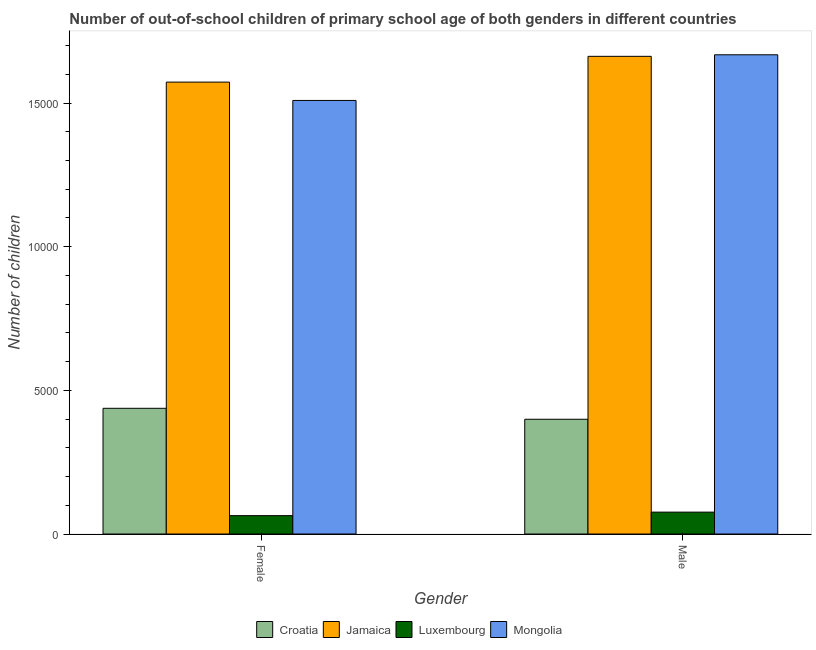How many bars are there on the 2nd tick from the left?
Your answer should be compact. 4. How many bars are there on the 1st tick from the right?
Give a very brief answer. 4. What is the label of the 1st group of bars from the left?
Give a very brief answer. Female. What is the number of female out-of-school students in Jamaica?
Your answer should be very brief. 1.57e+04. Across all countries, what is the maximum number of female out-of-school students?
Offer a very short reply. 1.57e+04. Across all countries, what is the minimum number of female out-of-school students?
Offer a terse response. 639. In which country was the number of male out-of-school students maximum?
Your answer should be compact. Mongolia. In which country was the number of female out-of-school students minimum?
Your response must be concise. Luxembourg. What is the total number of male out-of-school students in the graph?
Give a very brief answer. 3.81e+04. What is the difference between the number of female out-of-school students in Croatia and that in Jamaica?
Make the answer very short. -1.14e+04. What is the difference between the number of female out-of-school students in Croatia and the number of male out-of-school students in Jamaica?
Provide a short and direct response. -1.23e+04. What is the average number of male out-of-school students per country?
Provide a succinct answer. 9515.25. What is the difference between the number of female out-of-school students and number of male out-of-school students in Croatia?
Your answer should be very brief. 381. What is the ratio of the number of male out-of-school students in Croatia to that in Luxembourg?
Provide a succinct answer. 5.25. In how many countries, is the number of female out-of-school students greater than the average number of female out-of-school students taken over all countries?
Keep it short and to the point. 2. What does the 4th bar from the left in Female represents?
Provide a short and direct response. Mongolia. What does the 4th bar from the right in Male represents?
Your answer should be very brief. Croatia. How many bars are there?
Give a very brief answer. 8. What is the difference between two consecutive major ticks on the Y-axis?
Keep it short and to the point. 5000. Does the graph contain any zero values?
Your answer should be compact. No. Where does the legend appear in the graph?
Your response must be concise. Bottom center. How many legend labels are there?
Offer a terse response. 4. What is the title of the graph?
Offer a very short reply. Number of out-of-school children of primary school age of both genders in different countries. What is the label or title of the X-axis?
Your response must be concise. Gender. What is the label or title of the Y-axis?
Offer a very short reply. Number of children. What is the Number of children of Croatia in Female?
Your response must be concise. 4375. What is the Number of children of Jamaica in Female?
Offer a terse response. 1.57e+04. What is the Number of children in Luxembourg in Female?
Provide a short and direct response. 639. What is the Number of children of Mongolia in Female?
Your answer should be very brief. 1.51e+04. What is the Number of children of Croatia in Male?
Offer a very short reply. 3994. What is the Number of children of Jamaica in Male?
Your response must be concise. 1.66e+04. What is the Number of children of Luxembourg in Male?
Provide a succinct answer. 761. What is the Number of children in Mongolia in Male?
Ensure brevity in your answer.  1.67e+04. Across all Gender, what is the maximum Number of children in Croatia?
Offer a very short reply. 4375. Across all Gender, what is the maximum Number of children in Jamaica?
Your answer should be very brief. 1.66e+04. Across all Gender, what is the maximum Number of children in Luxembourg?
Ensure brevity in your answer.  761. Across all Gender, what is the maximum Number of children of Mongolia?
Give a very brief answer. 1.67e+04. Across all Gender, what is the minimum Number of children in Croatia?
Offer a terse response. 3994. Across all Gender, what is the minimum Number of children in Jamaica?
Keep it short and to the point. 1.57e+04. Across all Gender, what is the minimum Number of children of Luxembourg?
Keep it short and to the point. 639. Across all Gender, what is the minimum Number of children of Mongolia?
Give a very brief answer. 1.51e+04. What is the total Number of children of Croatia in the graph?
Your answer should be compact. 8369. What is the total Number of children in Jamaica in the graph?
Make the answer very short. 3.24e+04. What is the total Number of children of Luxembourg in the graph?
Provide a short and direct response. 1400. What is the total Number of children of Mongolia in the graph?
Provide a succinct answer. 3.18e+04. What is the difference between the Number of children of Croatia in Female and that in Male?
Your answer should be very brief. 381. What is the difference between the Number of children of Jamaica in Female and that in Male?
Your response must be concise. -897. What is the difference between the Number of children in Luxembourg in Female and that in Male?
Ensure brevity in your answer.  -122. What is the difference between the Number of children in Mongolia in Female and that in Male?
Make the answer very short. -1589. What is the difference between the Number of children in Croatia in Female and the Number of children in Jamaica in Male?
Make the answer very short. -1.23e+04. What is the difference between the Number of children in Croatia in Female and the Number of children in Luxembourg in Male?
Offer a terse response. 3614. What is the difference between the Number of children of Croatia in Female and the Number of children of Mongolia in Male?
Make the answer very short. -1.23e+04. What is the difference between the Number of children of Jamaica in Female and the Number of children of Luxembourg in Male?
Your answer should be very brief. 1.50e+04. What is the difference between the Number of children of Jamaica in Female and the Number of children of Mongolia in Male?
Ensure brevity in your answer.  -951. What is the difference between the Number of children of Luxembourg in Female and the Number of children of Mongolia in Male?
Provide a succinct answer. -1.60e+04. What is the average Number of children in Croatia per Gender?
Your response must be concise. 4184.5. What is the average Number of children in Jamaica per Gender?
Make the answer very short. 1.62e+04. What is the average Number of children in Luxembourg per Gender?
Provide a succinct answer. 700. What is the average Number of children in Mongolia per Gender?
Keep it short and to the point. 1.59e+04. What is the difference between the Number of children in Croatia and Number of children in Jamaica in Female?
Keep it short and to the point. -1.14e+04. What is the difference between the Number of children of Croatia and Number of children of Luxembourg in Female?
Make the answer very short. 3736. What is the difference between the Number of children in Croatia and Number of children in Mongolia in Female?
Provide a short and direct response. -1.07e+04. What is the difference between the Number of children of Jamaica and Number of children of Luxembourg in Female?
Your response must be concise. 1.51e+04. What is the difference between the Number of children in Jamaica and Number of children in Mongolia in Female?
Provide a short and direct response. 638. What is the difference between the Number of children of Luxembourg and Number of children of Mongolia in Female?
Ensure brevity in your answer.  -1.45e+04. What is the difference between the Number of children of Croatia and Number of children of Jamaica in Male?
Keep it short and to the point. -1.26e+04. What is the difference between the Number of children in Croatia and Number of children in Luxembourg in Male?
Provide a short and direct response. 3233. What is the difference between the Number of children in Croatia and Number of children in Mongolia in Male?
Give a very brief answer. -1.27e+04. What is the difference between the Number of children in Jamaica and Number of children in Luxembourg in Male?
Provide a short and direct response. 1.59e+04. What is the difference between the Number of children in Jamaica and Number of children in Mongolia in Male?
Keep it short and to the point. -54. What is the difference between the Number of children of Luxembourg and Number of children of Mongolia in Male?
Offer a terse response. -1.59e+04. What is the ratio of the Number of children in Croatia in Female to that in Male?
Keep it short and to the point. 1.1. What is the ratio of the Number of children of Jamaica in Female to that in Male?
Offer a very short reply. 0.95. What is the ratio of the Number of children in Luxembourg in Female to that in Male?
Offer a terse response. 0.84. What is the ratio of the Number of children of Mongolia in Female to that in Male?
Your answer should be very brief. 0.9. What is the difference between the highest and the second highest Number of children of Croatia?
Make the answer very short. 381. What is the difference between the highest and the second highest Number of children of Jamaica?
Make the answer very short. 897. What is the difference between the highest and the second highest Number of children of Luxembourg?
Keep it short and to the point. 122. What is the difference between the highest and the second highest Number of children of Mongolia?
Your response must be concise. 1589. What is the difference between the highest and the lowest Number of children of Croatia?
Ensure brevity in your answer.  381. What is the difference between the highest and the lowest Number of children of Jamaica?
Your response must be concise. 897. What is the difference between the highest and the lowest Number of children in Luxembourg?
Your response must be concise. 122. What is the difference between the highest and the lowest Number of children of Mongolia?
Ensure brevity in your answer.  1589. 